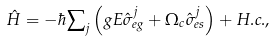Convert formula to latex. <formula><loc_0><loc_0><loc_500><loc_500>\hat { H } = - \hbar { \sum } _ { j } \left ( g E \hat { \sigma } _ { e g } ^ { j } + \Omega _ { c } \hat { \sigma } _ { e s } ^ { j } \right ) + H . c . ,</formula> 